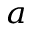<formula> <loc_0><loc_0><loc_500><loc_500>^ { a }</formula> 